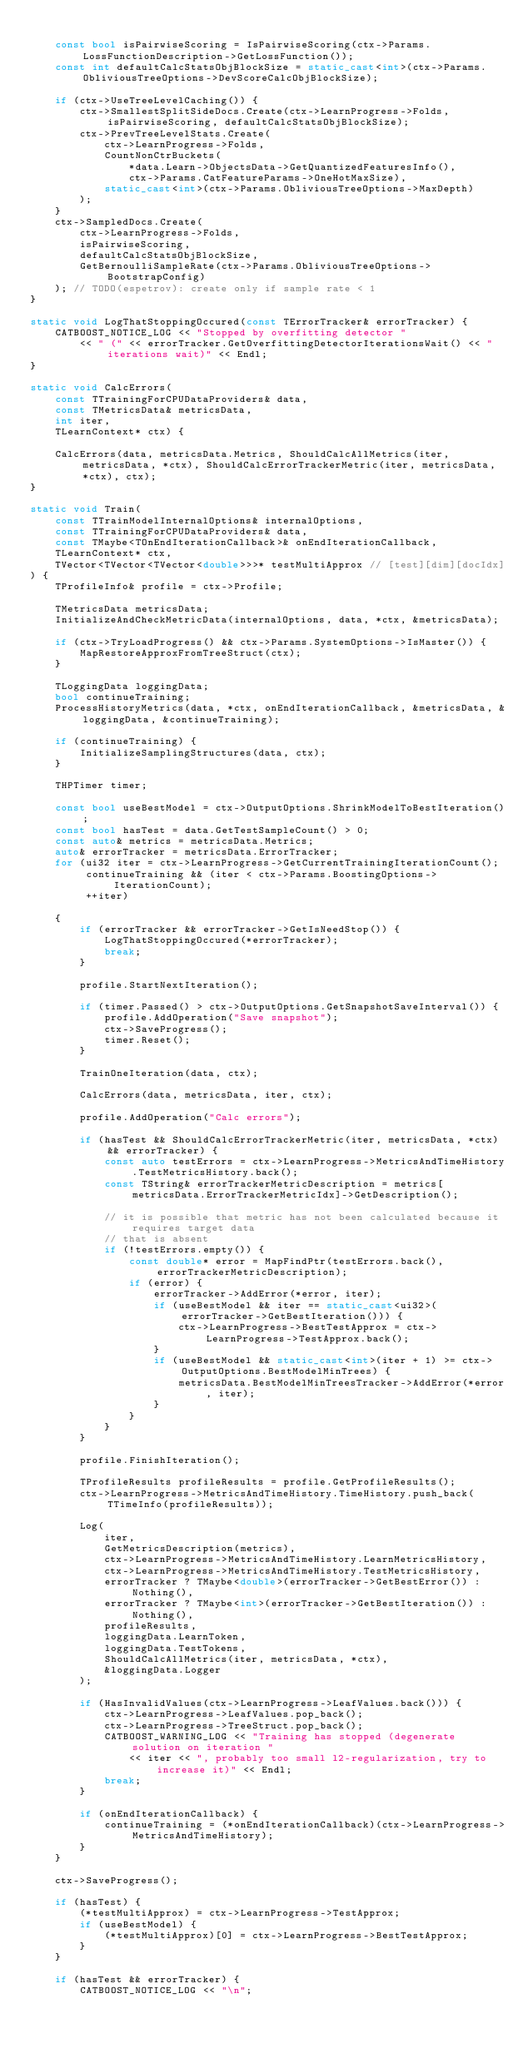<code> <loc_0><loc_0><loc_500><loc_500><_C++_>
    const bool isPairwiseScoring = IsPairwiseScoring(ctx->Params.LossFunctionDescription->GetLossFunction());
    const int defaultCalcStatsObjBlockSize = static_cast<int>(ctx->Params.ObliviousTreeOptions->DevScoreCalcObjBlockSize);

    if (ctx->UseTreeLevelCaching()) {
        ctx->SmallestSplitSideDocs.Create(ctx->LearnProgress->Folds, isPairwiseScoring, defaultCalcStatsObjBlockSize);
        ctx->PrevTreeLevelStats.Create(
            ctx->LearnProgress->Folds,
            CountNonCtrBuckets(
                *data.Learn->ObjectsData->GetQuantizedFeaturesInfo(),
                ctx->Params.CatFeatureParams->OneHotMaxSize),
            static_cast<int>(ctx->Params.ObliviousTreeOptions->MaxDepth)
        );
    }
    ctx->SampledDocs.Create(
        ctx->LearnProgress->Folds,
        isPairwiseScoring,
        defaultCalcStatsObjBlockSize,
        GetBernoulliSampleRate(ctx->Params.ObliviousTreeOptions->BootstrapConfig)
    ); // TODO(espetrov): create only if sample rate < 1
}

static void LogThatStoppingOccured(const TErrorTracker& errorTracker) {
    CATBOOST_NOTICE_LOG << "Stopped by overfitting detector "
        << " (" << errorTracker.GetOverfittingDetectorIterationsWait() << " iterations wait)" << Endl;
}

static void CalcErrors(
    const TTrainingForCPUDataProviders& data,
    const TMetricsData& metricsData,
    int iter,
    TLearnContext* ctx) {

    CalcErrors(data, metricsData.Metrics, ShouldCalcAllMetrics(iter, metricsData, *ctx), ShouldCalcErrorTrackerMetric(iter, metricsData, *ctx), ctx);
}

static void Train(
    const TTrainModelInternalOptions& internalOptions,
    const TTrainingForCPUDataProviders& data,
    const TMaybe<TOnEndIterationCallback>& onEndIterationCallback,
    TLearnContext* ctx,
    TVector<TVector<TVector<double>>>* testMultiApprox // [test][dim][docIdx]
) {
    TProfileInfo& profile = ctx->Profile;

    TMetricsData metricsData;
    InitializeAndCheckMetricData(internalOptions, data, *ctx, &metricsData);

    if (ctx->TryLoadProgress() && ctx->Params.SystemOptions->IsMaster()) {
        MapRestoreApproxFromTreeStruct(ctx);
    }

    TLoggingData loggingData;
    bool continueTraining;
    ProcessHistoryMetrics(data, *ctx, onEndIterationCallback, &metricsData, &loggingData, &continueTraining);

    if (continueTraining) {
        InitializeSamplingStructures(data, ctx);
    }

    THPTimer timer;

    const bool useBestModel = ctx->OutputOptions.ShrinkModelToBestIteration();
    const bool hasTest = data.GetTestSampleCount() > 0;
    const auto& metrics = metricsData.Metrics;
    auto& errorTracker = metricsData.ErrorTracker;
    for (ui32 iter = ctx->LearnProgress->GetCurrentTrainingIterationCount();
         continueTraining && (iter < ctx->Params.BoostingOptions->IterationCount);
         ++iter)

    {
        if (errorTracker && errorTracker->GetIsNeedStop()) {
            LogThatStoppingOccured(*errorTracker);
            break;
        }

        profile.StartNextIteration();

        if (timer.Passed() > ctx->OutputOptions.GetSnapshotSaveInterval()) {
            profile.AddOperation("Save snapshot");
            ctx->SaveProgress();
            timer.Reset();
        }

        TrainOneIteration(data, ctx);

        CalcErrors(data, metricsData, iter, ctx);

        profile.AddOperation("Calc errors");

        if (hasTest && ShouldCalcErrorTrackerMetric(iter, metricsData, *ctx) && errorTracker) {
            const auto testErrors = ctx->LearnProgress->MetricsAndTimeHistory.TestMetricsHistory.back();
            const TString& errorTrackerMetricDescription = metrics[metricsData.ErrorTrackerMetricIdx]->GetDescription();

            // it is possible that metric has not been calculated because it requires target data
            // that is absent
            if (!testErrors.empty()) {
                const double* error = MapFindPtr(testErrors.back(), errorTrackerMetricDescription);
                if (error) {
                    errorTracker->AddError(*error, iter);
                    if (useBestModel && iter == static_cast<ui32>(errorTracker->GetBestIteration())) {
                        ctx->LearnProgress->BestTestApprox = ctx->LearnProgress->TestApprox.back();
                    }
                    if (useBestModel && static_cast<int>(iter + 1) >= ctx->OutputOptions.BestModelMinTrees) {
                        metricsData.BestModelMinTreesTracker->AddError(*error, iter);
                    }
                }
            }
        }

        profile.FinishIteration();

        TProfileResults profileResults = profile.GetProfileResults();
        ctx->LearnProgress->MetricsAndTimeHistory.TimeHistory.push_back(TTimeInfo(profileResults));

        Log(
            iter,
            GetMetricsDescription(metrics),
            ctx->LearnProgress->MetricsAndTimeHistory.LearnMetricsHistory,
            ctx->LearnProgress->MetricsAndTimeHistory.TestMetricsHistory,
            errorTracker ? TMaybe<double>(errorTracker->GetBestError()) : Nothing(),
            errorTracker ? TMaybe<int>(errorTracker->GetBestIteration()) : Nothing(),
            profileResults,
            loggingData.LearnToken,
            loggingData.TestTokens,
            ShouldCalcAllMetrics(iter, metricsData, *ctx),
            &loggingData.Logger
        );

        if (HasInvalidValues(ctx->LearnProgress->LeafValues.back())) {
            ctx->LearnProgress->LeafValues.pop_back();
            ctx->LearnProgress->TreeStruct.pop_back();
            CATBOOST_WARNING_LOG << "Training has stopped (degenerate solution on iteration "
                << iter << ", probably too small l2-regularization, try to increase it)" << Endl;
            break;
        }

        if (onEndIterationCallback) {
            continueTraining = (*onEndIterationCallback)(ctx->LearnProgress->MetricsAndTimeHistory);
        }
    }

    ctx->SaveProgress();

    if (hasTest) {
        (*testMultiApprox) = ctx->LearnProgress->TestApprox;
        if (useBestModel) {
            (*testMultiApprox)[0] = ctx->LearnProgress->BestTestApprox;
        }
    }

    if (hasTest && errorTracker) {
        CATBOOST_NOTICE_LOG << "\n";</code> 